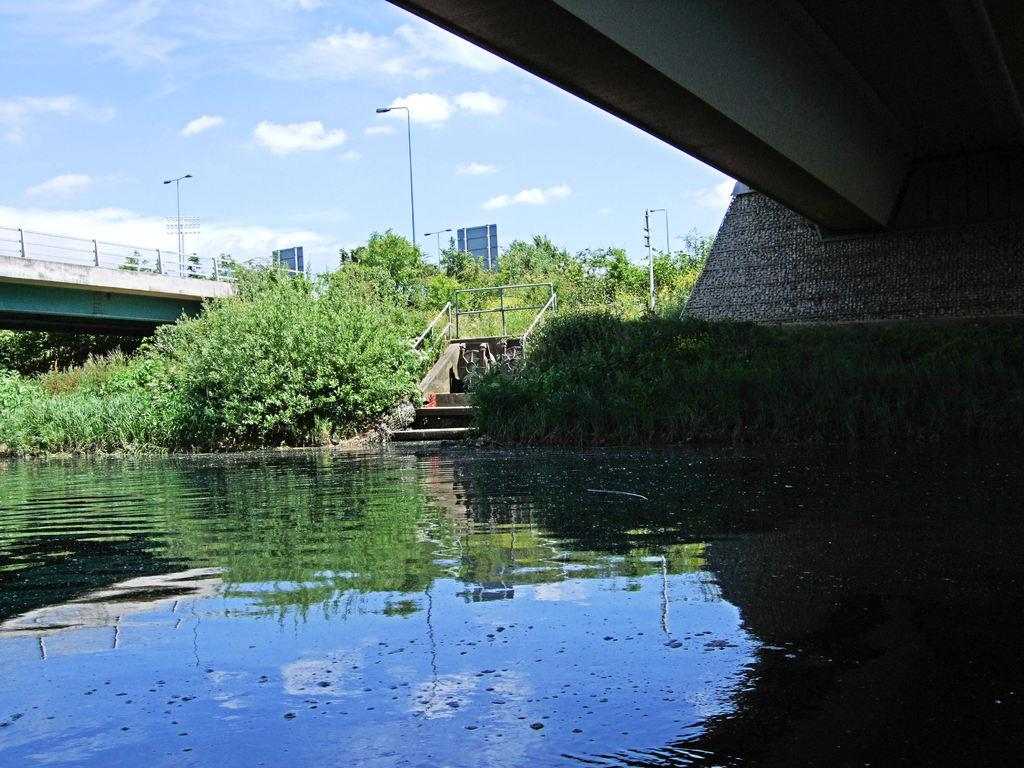What is in the foreground of the image? In the foreground of the image, there is water, a staircase, and plants. What type of structure can be seen in the image? There is a bridge visible in the image. What are the light poles used for in the image? The light poles are present in the image to provide illumination. What type of vegetation is visible in the image? Trees are visible in the image. What part of the natural environment is visible in the image? The sky is visible in the image. When was the image taken? The image was taken during the daytime. Can you tell me how many cords are attached to the trees in the image? There are no cords attached to the trees in the image. What type of respect is shown by the plants in the image? The plants in the image do not show any form of respect, as they are inanimate objects. 